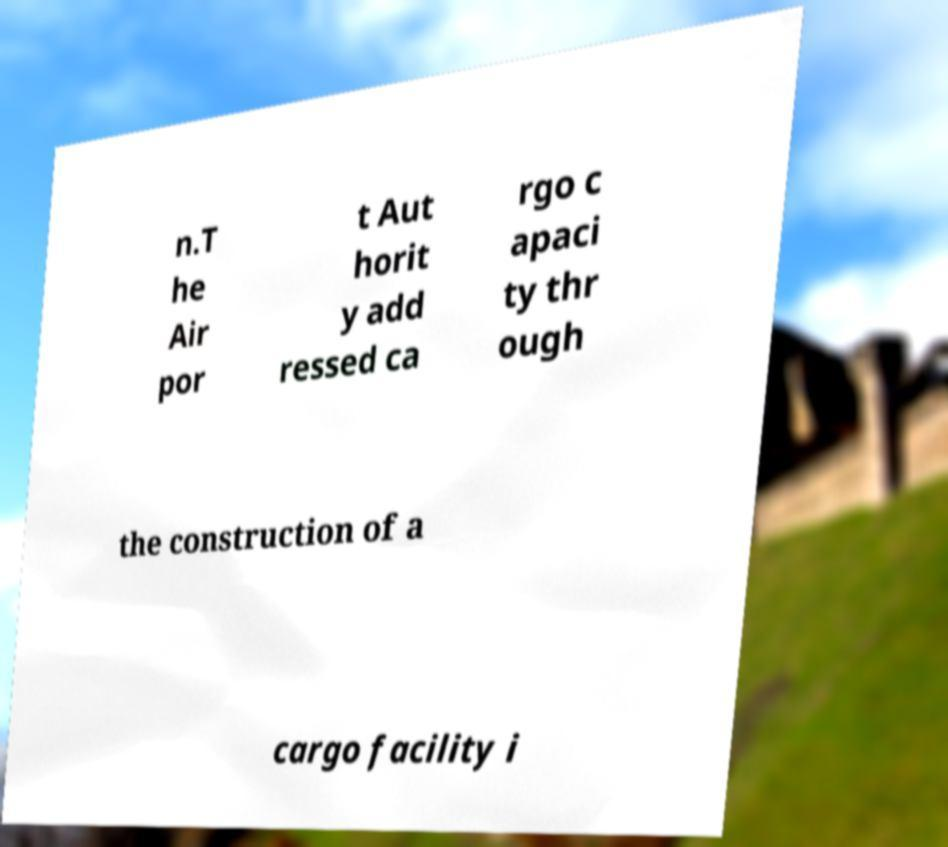I need the written content from this picture converted into text. Can you do that? n.T he Air por t Aut horit y add ressed ca rgo c apaci ty thr ough the construction of a cargo facility i 